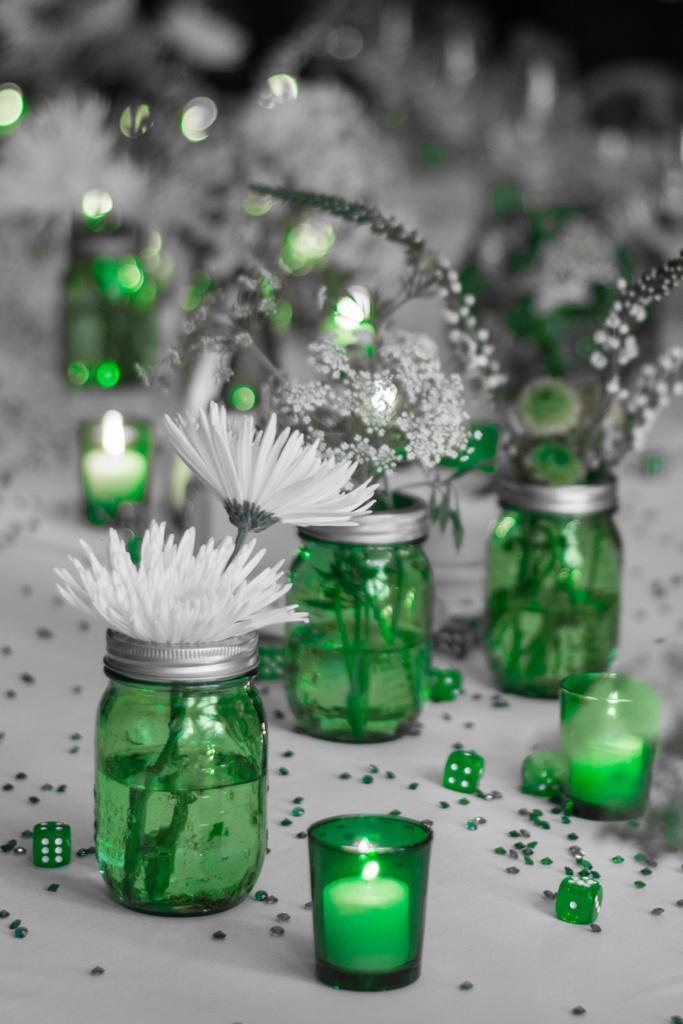Describe this image in one or two sentences. in this picture we can see the sum of the glasses in that glasses candles are present some bottles are over hear in that different types of flowers are arranged hear in that bottle we have some water in this picture we can see stones and dies are present. 